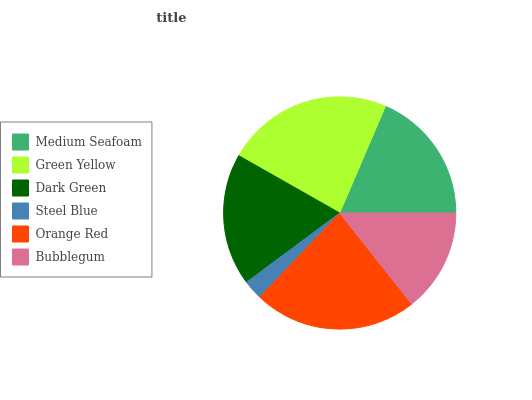Is Steel Blue the minimum?
Answer yes or no. Yes. Is Green Yellow the maximum?
Answer yes or no. Yes. Is Dark Green the minimum?
Answer yes or no. No. Is Dark Green the maximum?
Answer yes or no. No. Is Green Yellow greater than Dark Green?
Answer yes or no. Yes. Is Dark Green less than Green Yellow?
Answer yes or no. Yes. Is Dark Green greater than Green Yellow?
Answer yes or no. No. Is Green Yellow less than Dark Green?
Answer yes or no. No. Is Medium Seafoam the high median?
Answer yes or no. Yes. Is Dark Green the low median?
Answer yes or no. Yes. Is Green Yellow the high median?
Answer yes or no. No. Is Steel Blue the low median?
Answer yes or no. No. 